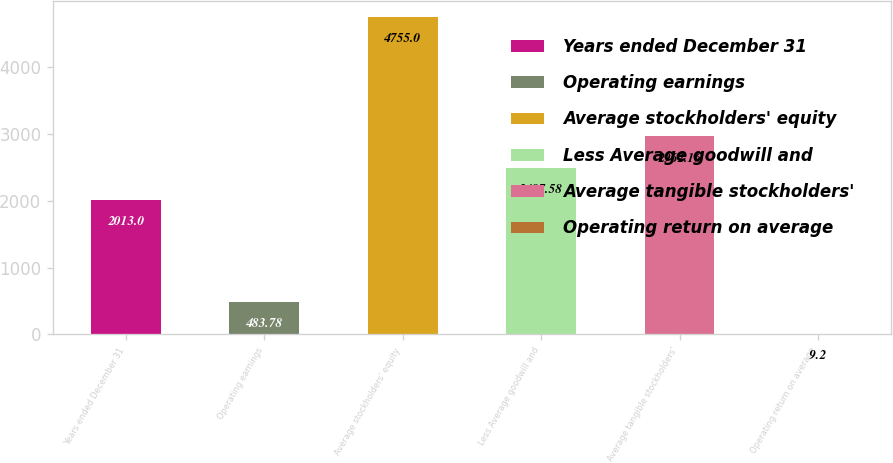<chart> <loc_0><loc_0><loc_500><loc_500><bar_chart><fcel>Years ended December 31<fcel>Operating earnings<fcel>Average stockholders' equity<fcel>Less Average goodwill and<fcel>Average tangible stockholders'<fcel>Operating return on average<nl><fcel>2013<fcel>483.78<fcel>4755<fcel>2487.58<fcel>2962.16<fcel>9.2<nl></chart> 